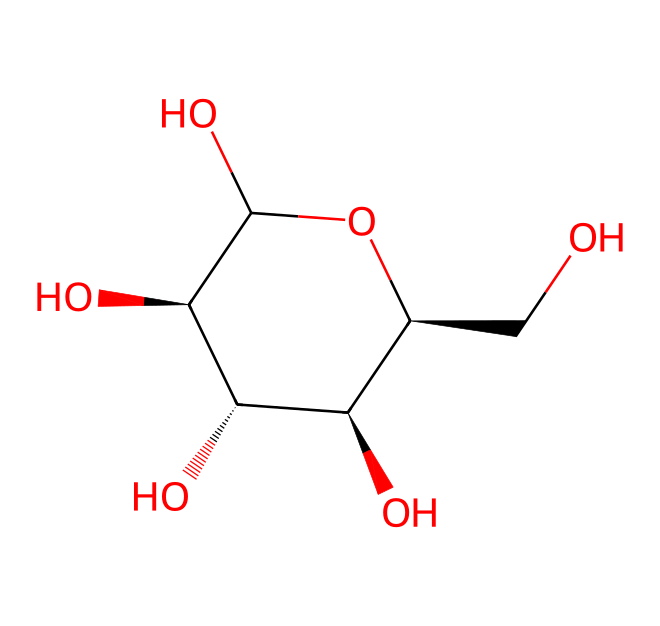How many carbon atoms are present in this structure? By examining the SMILES notation, we can see the 'C' symbols represent carbon atoms. Counting each 'C', we find there are six carbon atoms in total.
Answer: six What is the primary function of cellulose in apple packaging materials? Cellulose provides structural support for plant cell walls. In packaging, it is used due to its strength and biodegradability, making it suitable for protecting apples during storage and transport.
Answer: structural support How many hydroxyl (–OH) groups are there in this molecule? The hydroxyl groups appear in the structure as 'O' that is connected to 'C' in the SMILES representation. Counting them in this structure shows there are four hydroxyl groups attached to the carbon atoms.
Answer: four Is this molecule a monosaccharide or a polysaccharide? The presence of multiple carbon rings and multiple hydroxyl groups indicates that this molecule is part of a polysaccharide, as cellulose is a polymer made up of multiple glucose units.
Answer: polysaccharide What type of linkage connects the glucose units in cellulose? Cellulose consists of beta-1,4-glycosidic linkages between the glucose units. This type of linkage helps form long, linear chains that improve cellulose's mechanical properties.
Answer: beta-1,4-glycosidic What kind of carbohydrate does this structure represent? This structure represents cellulose, a homopolymer of glucose. It is a carbohydrate known for its structural role in plants and is commonly found in plant fibers.
Answer: cellulose 